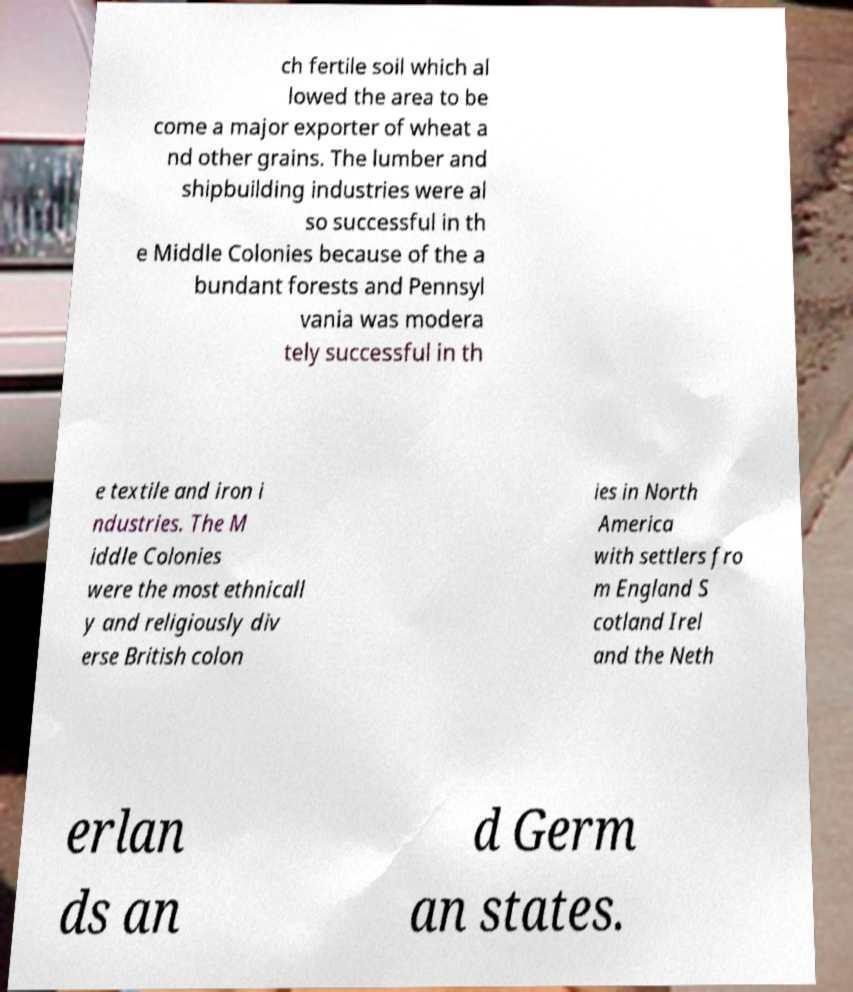For documentation purposes, I need the text within this image transcribed. Could you provide that? ch fertile soil which al lowed the area to be come a major exporter of wheat a nd other grains. The lumber and shipbuilding industries were al so successful in th e Middle Colonies because of the a bundant forests and Pennsyl vania was modera tely successful in th e textile and iron i ndustries. The M iddle Colonies were the most ethnicall y and religiously div erse British colon ies in North America with settlers fro m England S cotland Irel and the Neth erlan ds an d Germ an states. 